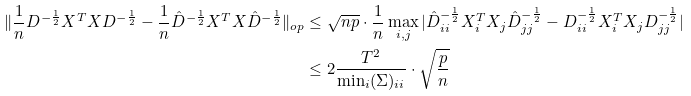Convert formula to latex. <formula><loc_0><loc_0><loc_500><loc_500>\| \frac { 1 } { n } D ^ { - \frac { 1 } { 2 } } X ^ { T } X D ^ { - \frac { 1 } { 2 } } - \frac { 1 } { n } \hat { D } ^ { - \frac { 1 } { 2 } } X ^ { T } X \hat { D } ^ { - \frac { 1 } { 2 } } \| _ { o p } & \leq \sqrt { n p } \cdot \frac { 1 } { n } \max _ { i , j } | \hat { D } _ { i i } ^ { - \frac { 1 } { 2 } } X _ { i } ^ { T } X _ { j } \hat { D } _ { j j } ^ { - \frac { 1 } { 2 } } - D _ { i i } ^ { - \frac { 1 } { 2 } } X _ { i } ^ { T } X _ { j } D _ { j j } ^ { - \frac { 1 } { 2 } } | \\ & \leq 2 \frac { T ^ { 2 } } { \min _ { i } ( \Sigma ) _ { i i } } \cdot \sqrt { \frac { p } { n } }</formula> 